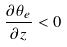<formula> <loc_0><loc_0><loc_500><loc_500>\frac { \partial \theta _ { e } } { \partial z } < 0</formula> 